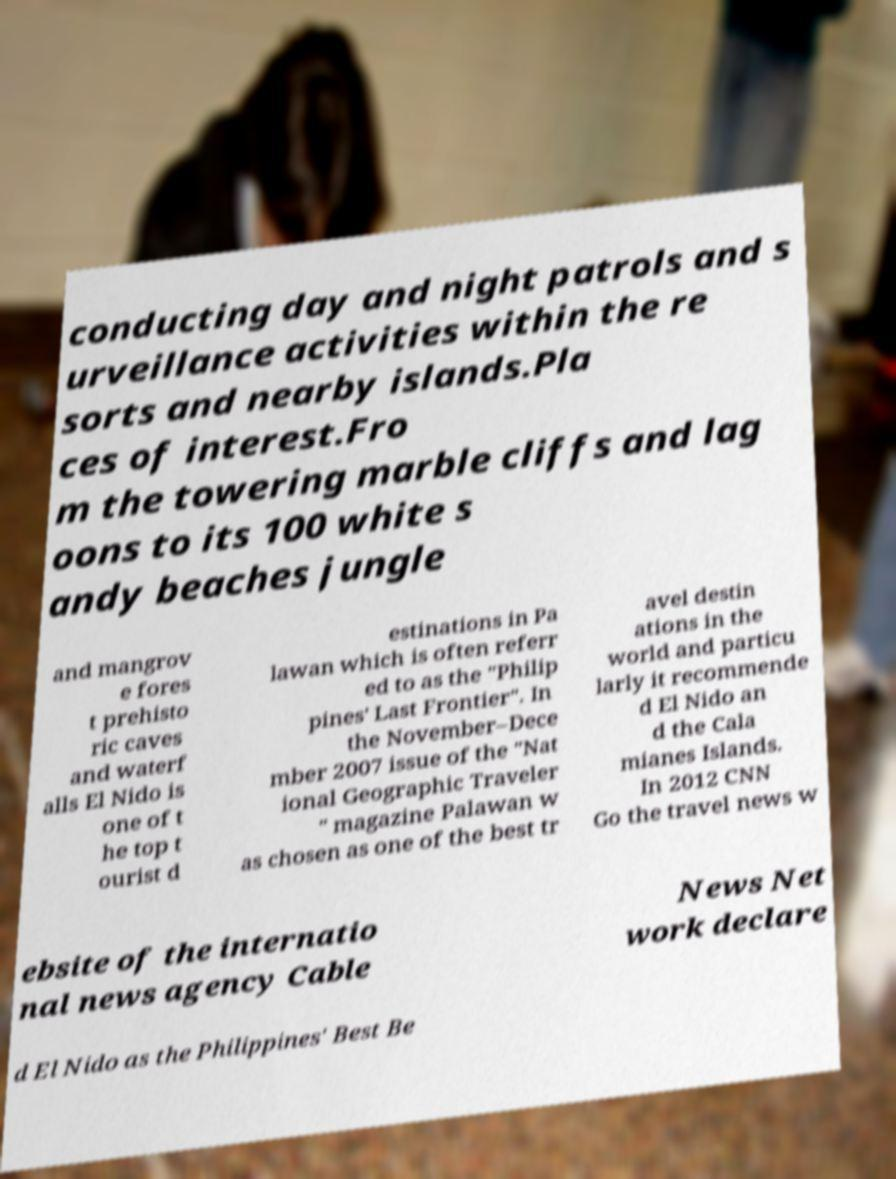Could you assist in decoding the text presented in this image and type it out clearly? conducting day and night patrols and s urveillance activities within the re sorts and nearby islands.Pla ces of interest.Fro m the towering marble cliffs and lag oons to its 100 white s andy beaches jungle and mangrov e fores t prehisto ric caves and waterf alls El Nido is one of t he top t ourist d estinations in Pa lawan which is often referr ed to as the "Philip pines' Last Frontier". In the November–Dece mber 2007 issue of the "Nat ional Geographic Traveler " magazine Palawan w as chosen as one of the best tr avel destin ations in the world and particu larly it recommende d El Nido an d the Cala mianes Islands. In 2012 CNN Go the travel news w ebsite of the internatio nal news agency Cable News Net work declare d El Nido as the Philippines' Best Be 